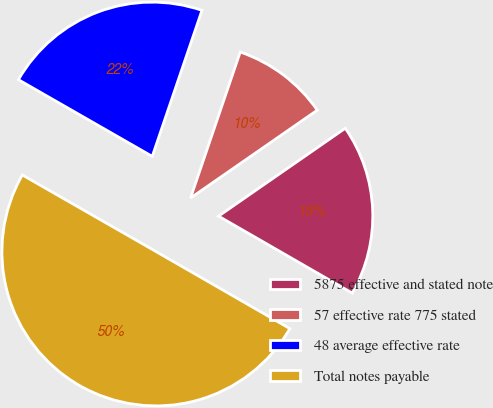<chart> <loc_0><loc_0><loc_500><loc_500><pie_chart><fcel>5875 effective and stated note<fcel>57 effective rate 775 stated<fcel>48 average effective rate<fcel>Total notes payable<nl><fcel>17.96%<fcel>10.13%<fcel>21.94%<fcel>49.97%<nl></chart> 